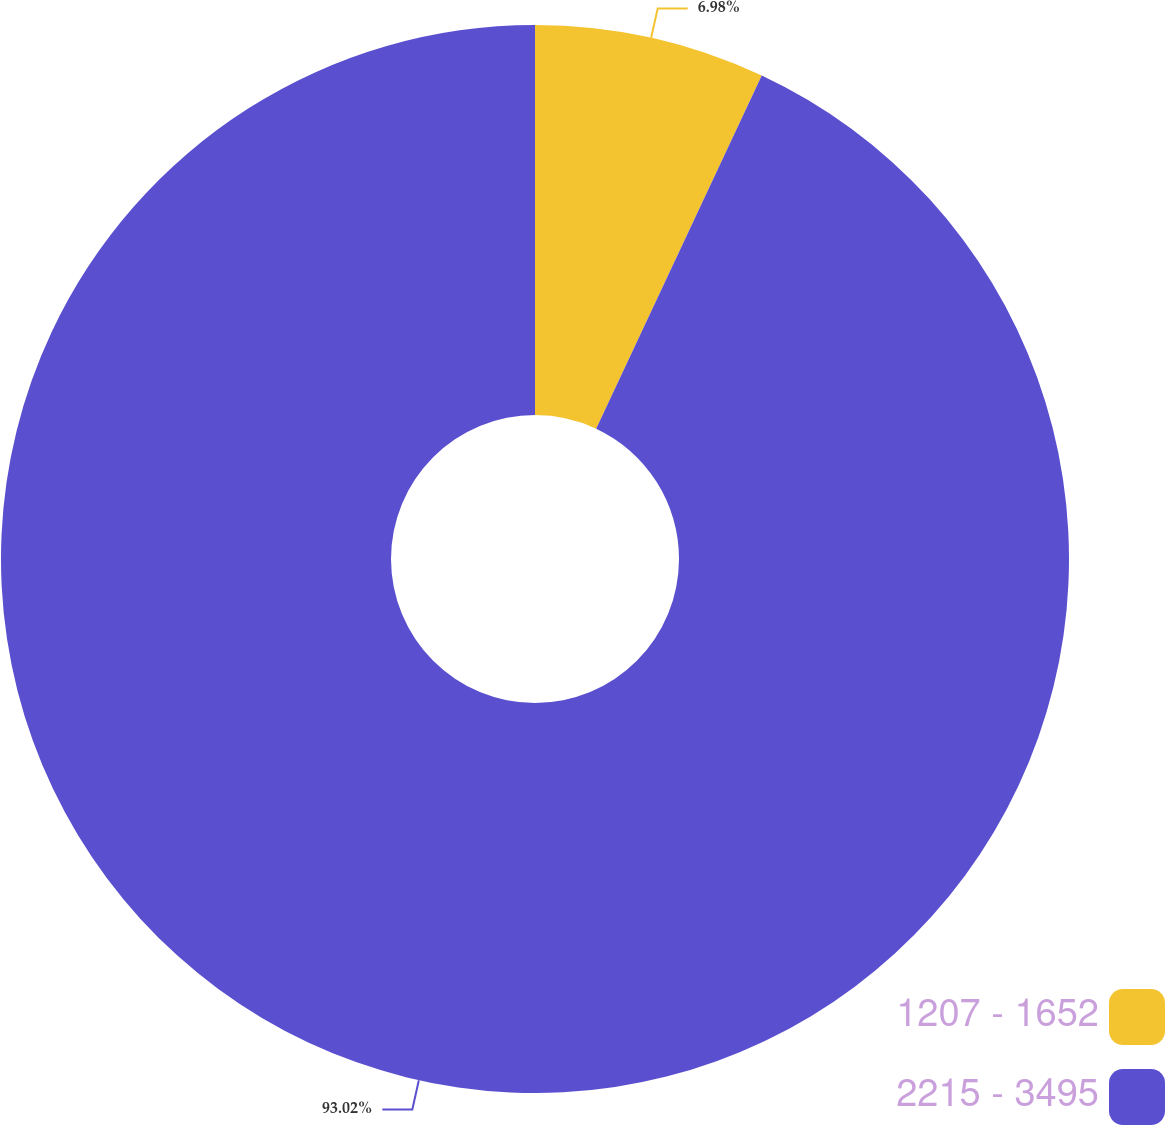Convert chart to OTSL. <chart><loc_0><loc_0><loc_500><loc_500><pie_chart><fcel>1207 - 1652<fcel>2215 - 3495<nl><fcel>6.98%<fcel>93.02%<nl></chart> 